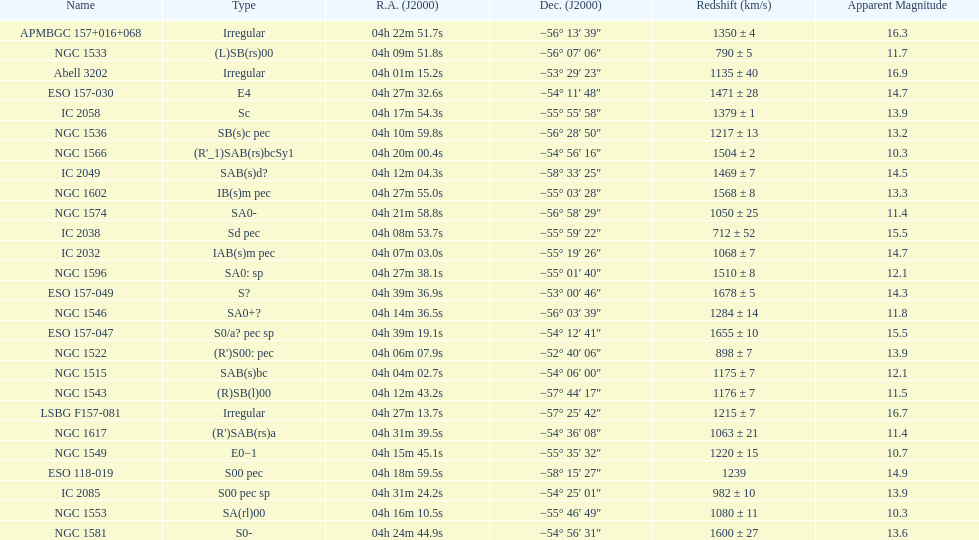Name the member with the highest apparent magnitude. Abell 3202. 